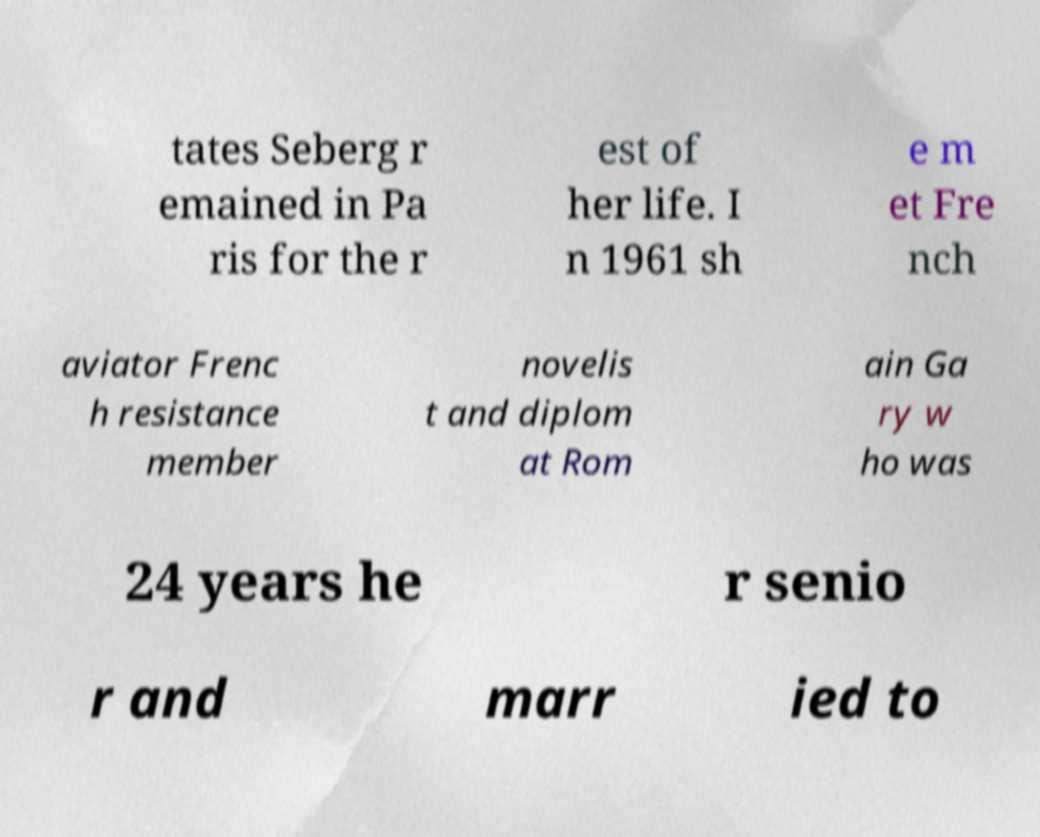Can you read and provide the text displayed in the image?This photo seems to have some interesting text. Can you extract and type it out for me? tates Seberg r emained in Pa ris for the r est of her life. I n 1961 sh e m et Fre nch aviator Frenc h resistance member novelis t and diplom at Rom ain Ga ry w ho was 24 years he r senio r and marr ied to 